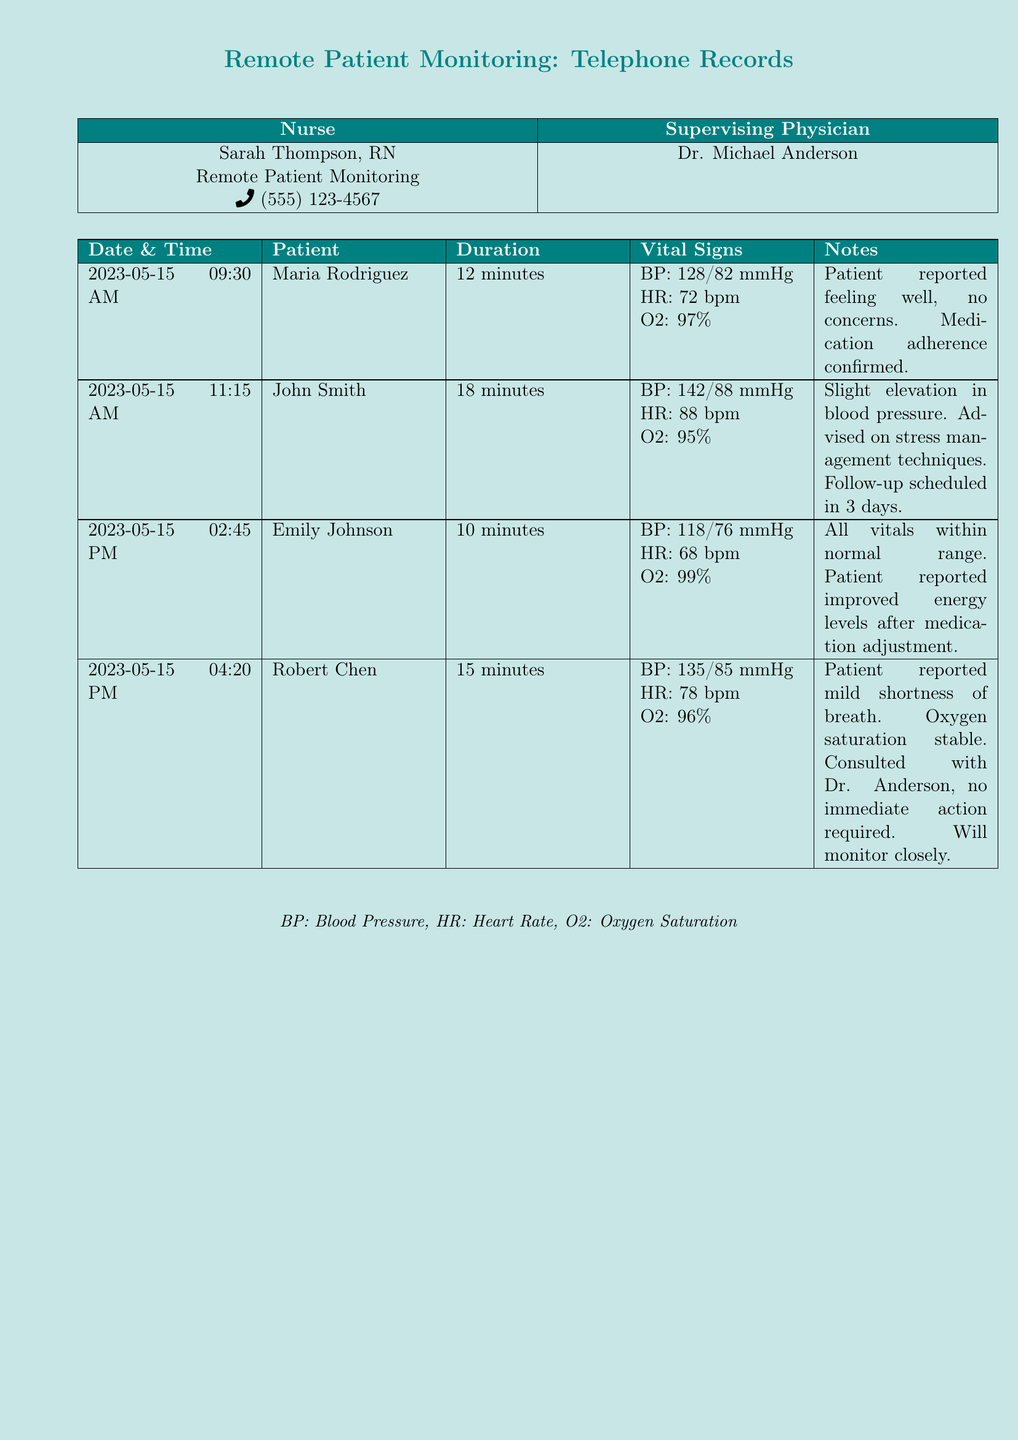What is the date of Maria Rodriguez's check-in? Maria Rodriguez's check-in was recorded on May 15, 2023, at 09:30 AM.
Answer: May 15, 2023 What was the duration of John Smith's call? The duration of John Smith's call was specified as 18 minutes.
Answer: 18 minutes What were Emily Johnson's vital signs? The vital signs for Emily Johnson showed a BP of 118/76 mmHg, HR of 68 bpm, and O2 at 99%.
Answer: BP: 118/76 mmHg, HR: 68 bpm, O2: 99% What is the blood pressure reading for Robert Chen? Robert Chen's blood pressure reading was 135/85 mmHg.
Answer: 135/85 mmHg What concerns did Maria Rodriguez report during her call? Maria Rodriguez reported feeling well and had no concerns during her call.
Answer: No concerns How many patients were checked in on May 15, 2023? The document lists four patients checked in on that date.
Answer: Four What advice was given to John Smith? John Smith was advised on stress management techniques due to his slight elevation in blood pressure.
Answer: Stress management techniques What was the oxygen saturation level of Robert Chen? The oxygen saturation level reported for Robert Chen was stable at 96%.
Answer: 96% What was the follow-up plan for John Smith? John Smith's follow-up plan was scheduled for 3 days later.
Answer: Follow-up in 3 days What did Emily Johnson report after the medication adjustment? Emily Johnson reported improved energy levels after her medication adjustment.
Answer: Improved energy levels 